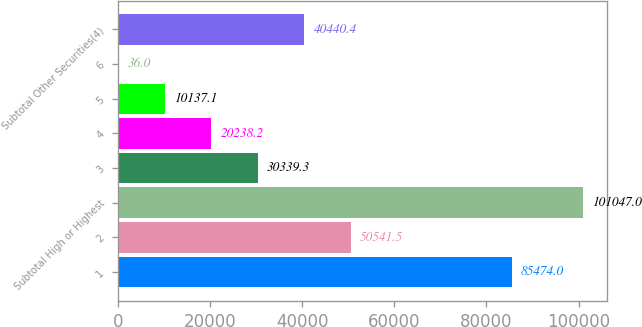Convert chart to OTSL. <chart><loc_0><loc_0><loc_500><loc_500><bar_chart><fcel>1<fcel>2<fcel>Subtotal High or Highest<fcel>3<fcel>4<fcel>5<fcel>6<fcel>Subtotal Other Securities(4)<nl><fcel>85474<fcel>50541.5<fcel>101047<fcel>30339.3<fcel>20238.2<fcel>10137.1<fcel>36<fcel>40440.4<nl></chart> 